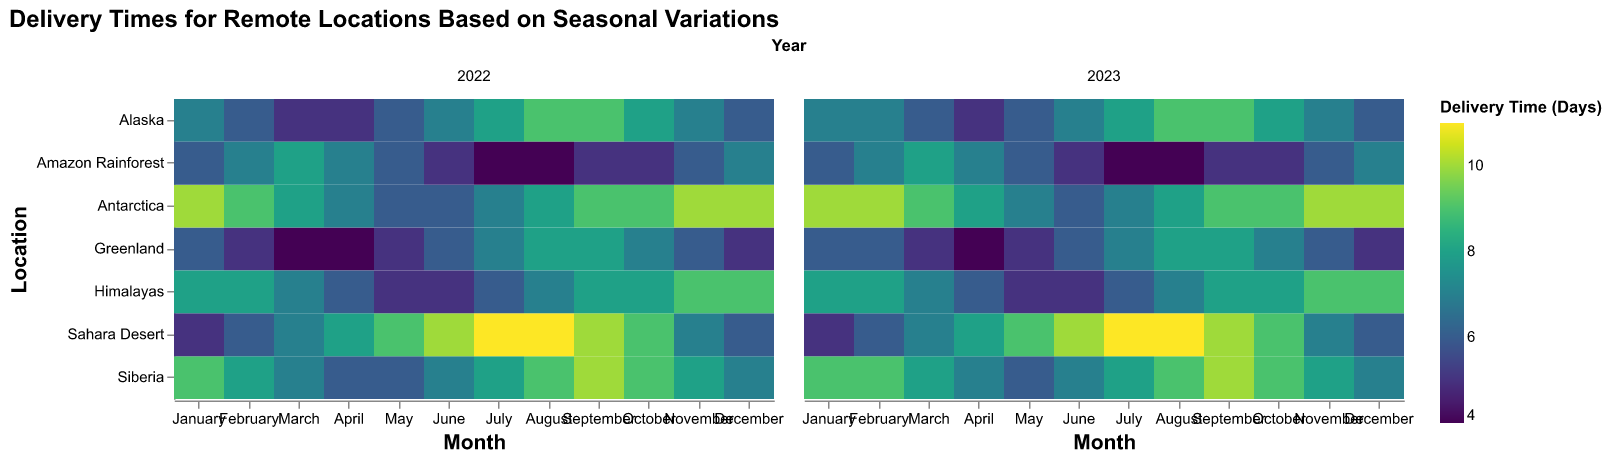Which location has the longest average delivery time across all months in 2022? The longest average delivery time can be found by looking for the location with the highest average color intensity for the year 2022. Antarctica shows the highest intensity most consistently throughout the months.
Answer: Antarctica How do the delivery times in Alaska in December 2023 compare to those in December 2022? In December 2022, the delivery time for Alaska is shown as a lighter shade compared to December 2023. By looking at the corresponding cells, both delivery times are 6 days.
Answer: Equal Which month has the shortest delivery times for the Amazon Rainforest in 2023? By observing the color intensity for the Amazon Rainforest row for the year 2023, the month of July is the lightest, indicating the shortest delivery time.
Answer: July What is the average delivery time for Greenland across all months in 2023? Sum the delivery times for each month in Greenland for the year 2023: (6 + 6 + 5 + 4 + 5 + 6 + 7 + 8 + 8 + 7 + 6 + 5) = 73. Divide by 12 to get the average. 73/12 ≈ 6.08.
Answer: Approximately 6.08 days Which location showed the most improvement in delivery times from January to December in 2022? Looking at the difference in color intensity from January to December in 2022, the Amazon Rainforest goes from a darker shade (6) in January to a lighter shade (7) in December, indicating an improvement in delivery times.
Answer: The Amazon Rainforest In which year do the delivery times in Antarctica show more consistency month-to-month? Antarctica in both years shows consistently high delivery times, visually by the little variation in color intensity month to month. However, 2023 shows more consistency as it has fewer month-to-month variations compared to 2022.
Answer: 2023 What is the difference in average delivery time between January and July for Sahara Desert in 2022? The delivery time in January for Sahara Desert in 2022 is 5 days and in July it is 11 days. The difference is 11 - 5 = 6 days.
Answer: 6 days Are the delivery times in the Himalayas lower in May or September in 2022? By comparing the color intensities, May has a lighter shade (5) while September has a darker shade (8) in 2022. Thus, May has lower delivery times.
Answer: May Which location has the highest delivery time in June across both years? By comparing the color intensities of all locations for the month of June, the Sahara Desert has the highest delivery time with a value of 10 days.
Answer: Sahara Desert How does Siberia's delivery time for March in 2022 compare to its delivery time in March 2023? Observing the color shades for Siberia in March for both years, 2022 has a lighter shade (7 days) compared to 2023 (8 days).
Answer: Higher in 2023 